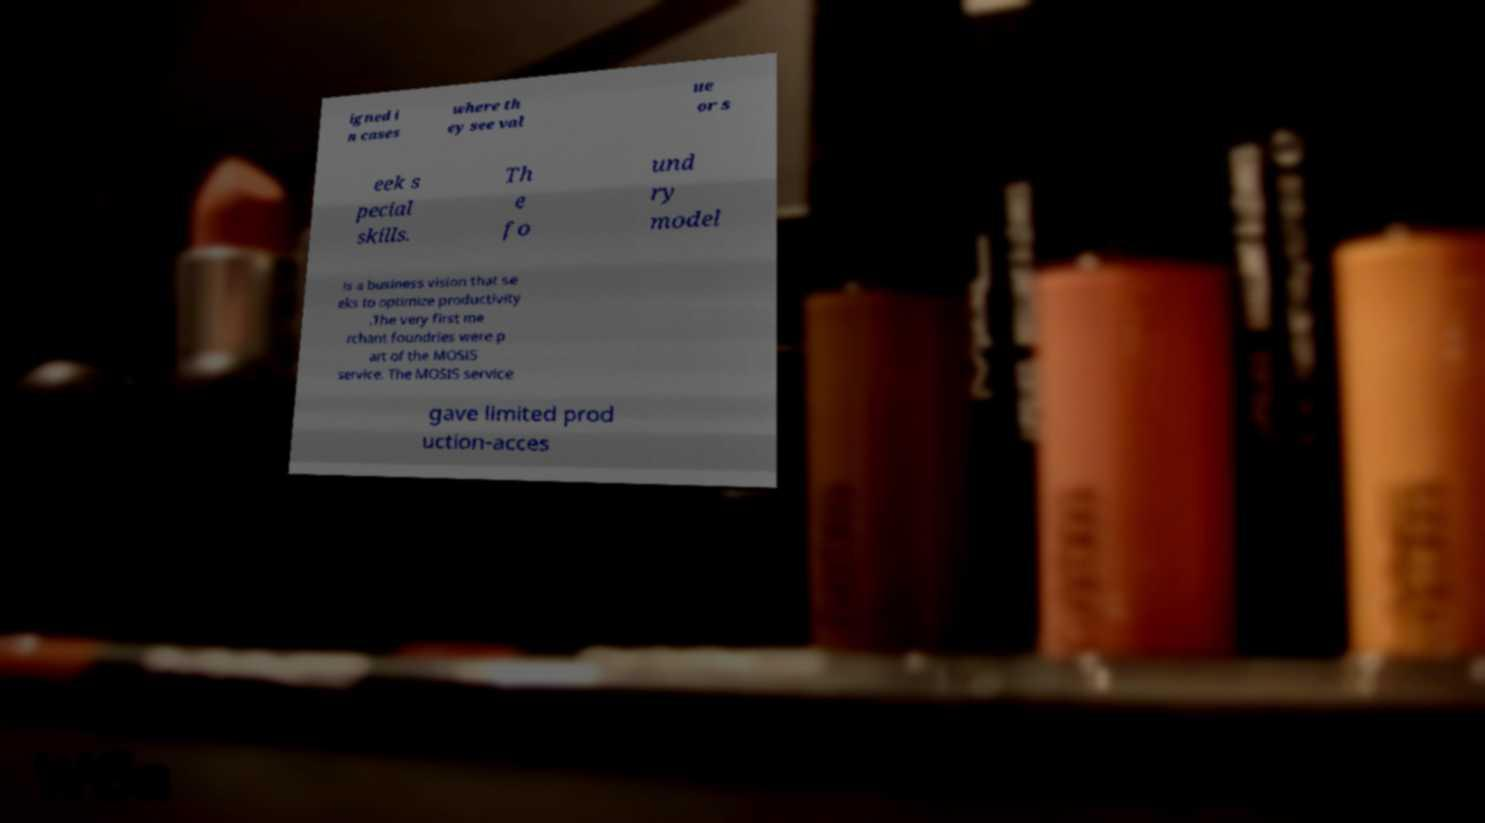Can you read and provide the text displayed in the image?This photo seems to have some interesting text. Can you extract and type it out for me? igned i n cases where th ey see val ue or s eek s pecial skills. Th e fo und ry model is a business vision that se eks to optimize productivity .The very first me rchant foundries were p art of the MOSIS service. The MOSIS service gave limited prod uction-acces 